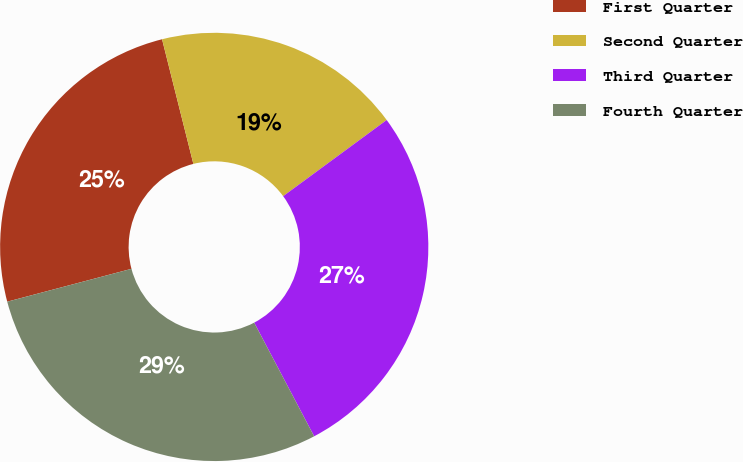Convert chart to OTSL. <chart><loc_0><loc_0><loc_500><loc_500><pie_chart><fcel>First Quarter<fcel>Second Quarter<fcel>Third Quarter<fcel>Fourth Quarter<nl><fcel>25.2%<fcel>18.82%<fcel>27.37%<fcel>28.61%<nl></chart> 